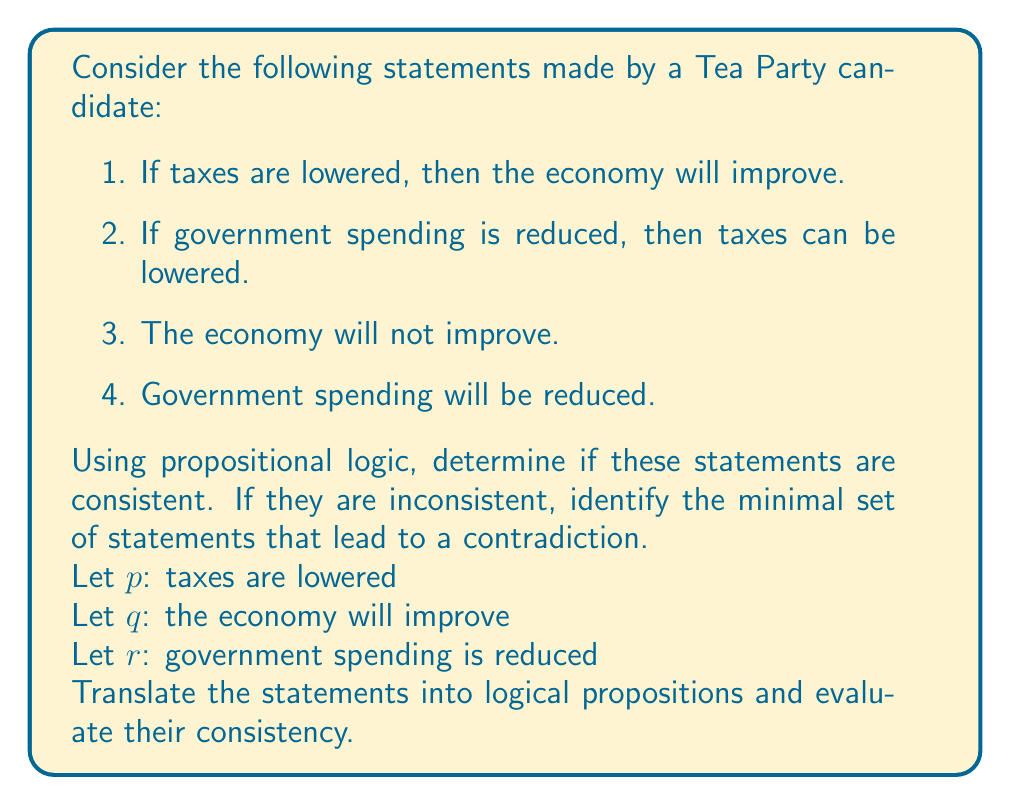Can you answer this question? Let's translate the statements into logical propositions:

1. $p \rightarrow q$
2. $r \rightarrow p$
3. $\neg q$
4. $r$

To check for consistency, we'll use a proof by contradiction. We'll assume all statements are true and see if we can derive a contradiction.

Step 1: From statement 4, we know $r$ is true.

Step 2: Since $r$ is true, and statement 2 says $r \rightarrow p$, we can conclude $p$ is true (by modus ponens).

Step 3: Now that $p$ is true, and statement 1 says $p \rightarrow q$, we can conclude $q$ is true (again by modus ponens).

Step 4: However, statement 3 explicitly states $\neg q$.

We've arrived at a contradiction: $q$ and $\neg q$ cannot both be true.

Therefore, these statements are inconsistent.

To find the minimal set of inconsistent statements, we need to identify which statements were necessary to derive the contradiction. In this case, we used statements 1, 2, 3, and 4 in our reasoning. Removing any one of these statements would eliminate the contradiction, so this set of four statements is minimal.
Answer: The statements are inconsistent. The minimal set of inconsistent statements includes all four given statements:

1. $p \rightarrow q$
2. $r \rightarrow p$
3. $\neg q$
4. $r$

These statements together lead to a logical contradiction. 